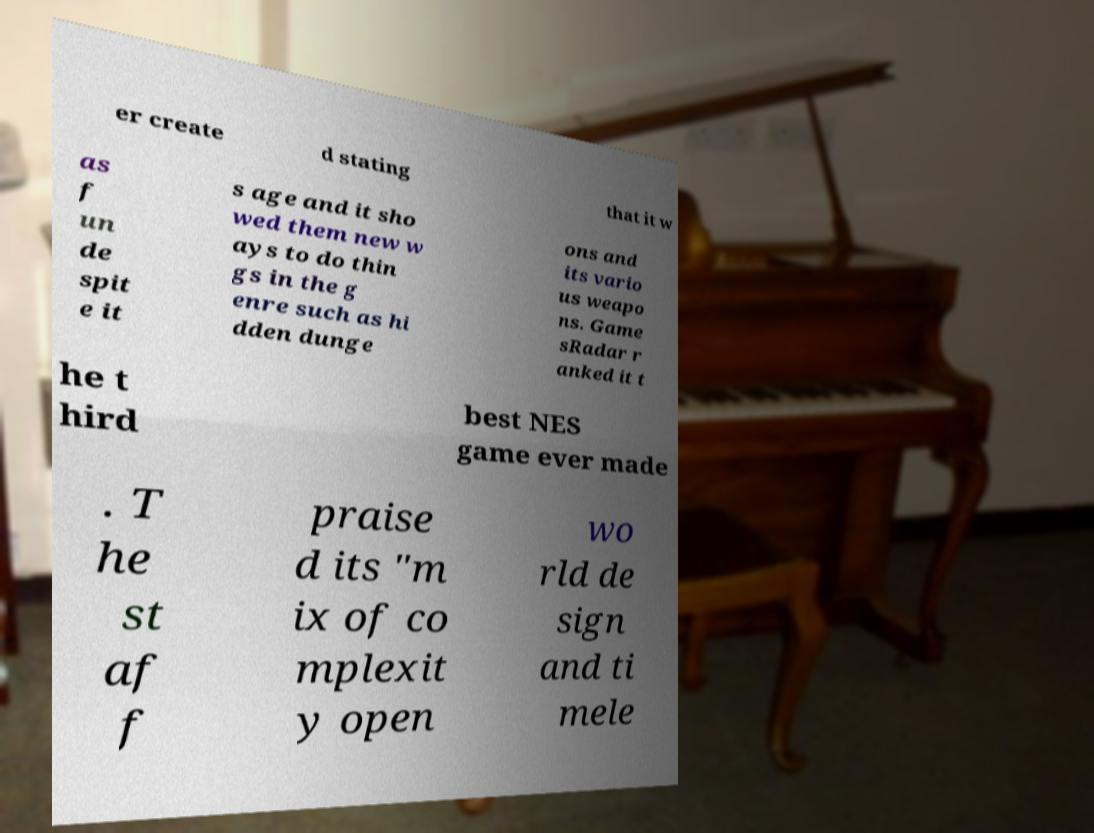Can you read and provide the text displayed in the image?This photo seems to have some interesting text. Can you extract and type it out for me? er create d stating that it w as f un de spit e it s age and it sho wed them new w ays to do thin gs in the g enre such as hi dden dunge ons and its vario us weapo ns. Game sRadar r anked it t he t hird best NES game ever made . T he st af f praise d its "m ix of co mplexit y open wo rld de sign and ti mele 